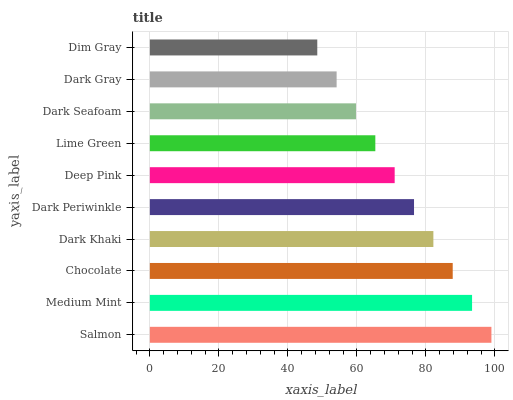Is Dim Gray the minimum?
Answer yes or no. Yes. Is Salmon the maximum?
Answer yes or no. Yes. Is Medium Mint the minimum?
Answer yes or no. No. Is Medium Mint the maximum?
Answer yes or no. No. Is Salmon greater than Medium Mint?
Answer yes or no. Yes. Is Medium Mint less than Salmon?
Answer yes or no. Yes. Is Medium Mint greater than Salmon?
Answer yes or no. No. Is Salmon less than Medium Mint?
Answer yes or no. No. Is Dark Periwinkle the high median?
Answer yes or no. Yes. Is Deep Pink the low median?
Answer yes or no. Yes. Is Dim Gray the high median?
Answer yes or no. No. Is Dark Gray the low median?
Answer yes or no. No. 